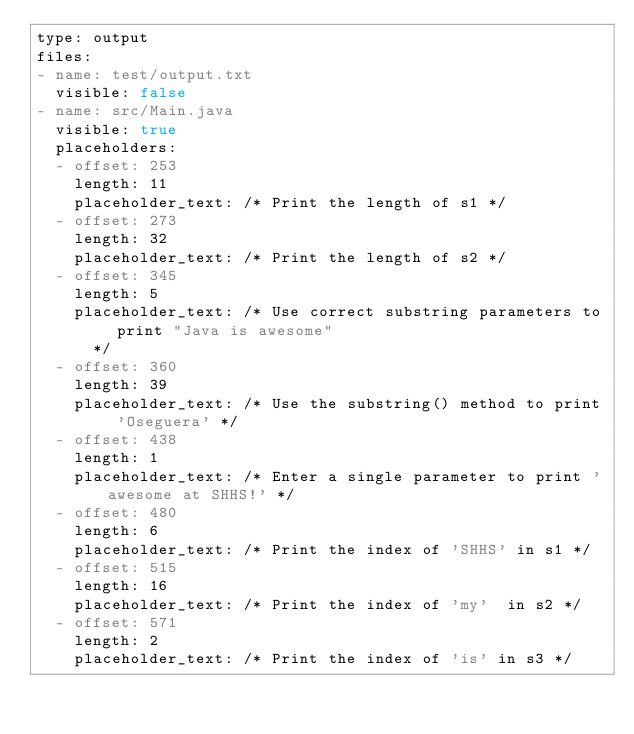<code> <loc_0><loc_0><loc_500><loc_500><_YAML_>type: output
files:
- name: test/output.txt
  visible: false
- name: src/Main.java
  visible: true
  placeholders:
  - offset: 253
    length: 11
    placeholder_text: /* Print the length of s1 */
  - offset: 273
    length: 32
    placeholder_text: /* Print the length of s2 */
  - offset: 345
    length: 5
    placeholder_text: /* Use correct substring parameters to print "Java is awesome"
      */
  - offset: 360
    length: 39
    placeholder_text: /* Use the substring() method to print 'Oseguera' */
  - offset: 438
    length: 1
    placeholder_text: /* Enter a single parameter to print 'awesome at SHHS!' */
  - offset: 480
    length: 6
    placeholder_text: /* Print the index of 'SHHS' in s1 */
  - offset: 515
    length: 16
    placeholder_text: /* Print the index of 'my'  in s2 */
  - offset: 571
    length: 2
    placeholder_text: /* Print the index of 'is' in s3 */
</code> 